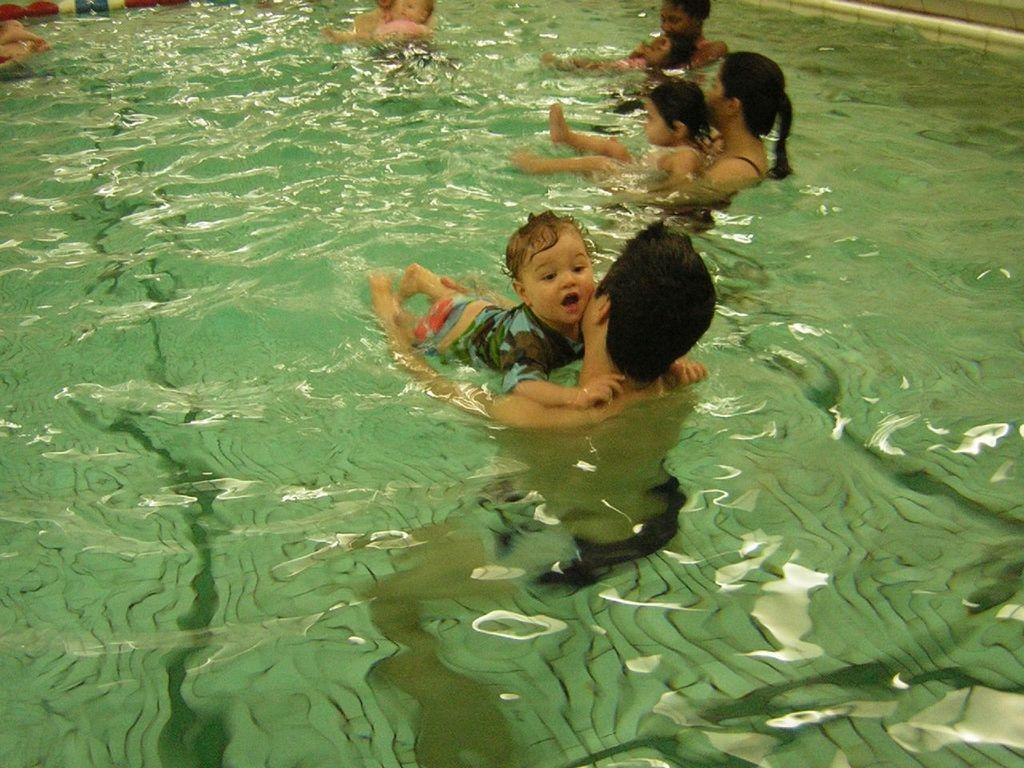What are the people in the image doing? The people in the image are swimming. Are there any additional objects or subjects in the image besides the people swimming? Yes, the people are holding babies in their hands. What type of copy machine can be seen in the image? There is no copy machine present in the image; it features people swimming and holding babies. 